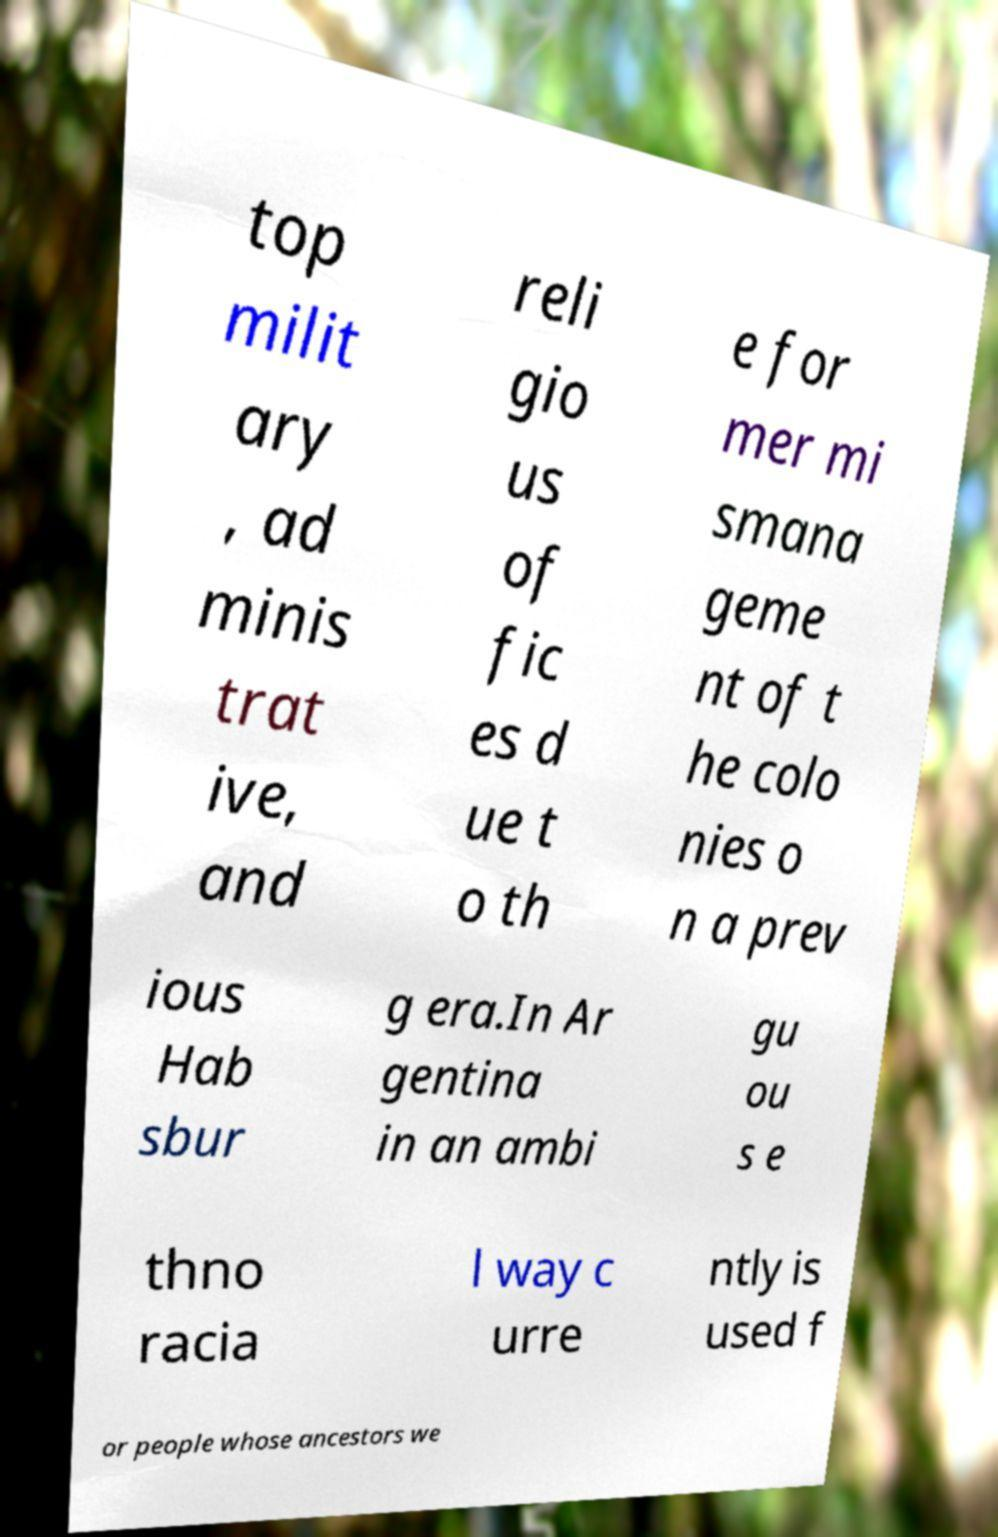What messages or text are displayed in this image? I need them in a readable, typed format. top milit ary , ad minis trat ive, and reli gio us of fic es d ue t o th e for mer mi smana geme nt of t he colo nies o n a prev ious Hab sbur g era.In Ar gentina in an ambi gu ou s e thno racia l way c urre ntly is used f or people whose ancestors we 